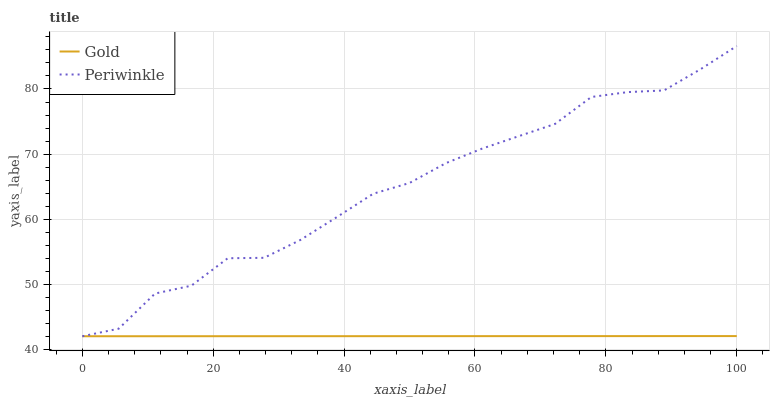Does Gold have the minimum area under the curve?
Answer yes or no. Yes. Does Periwinkle have the maximum area under the curve?
Answer yes or no. Yes. Does Gold have the maximum area under the curve?
Answer yes or no. No. Is Gold the smoothest?
Answer yes or no. Yes. Is Periwinkle the roughest?
Answer yes or no. Yes. Is Gold the roughest?
Answer yes or no. No. Does Periwinkle have the lowest value?
Answer yes or no. Yes. Does Periwinkle have the highest value?
Answer yes or no. Yes. Does Gold have the highest value?
Answer yes or no. No. Does Periwinkle intersect Gold?
Answer yes or no. Yes. Is Periwinkle less than Gold?
Answer yes or no. No. Is Periwinkle greater than Gold?
Answer yes or no. No. 